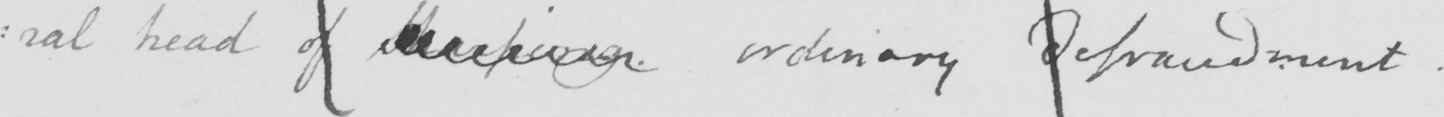Can you tell me what this handwritten text says? head of Sharping. ordinary defraudment. 